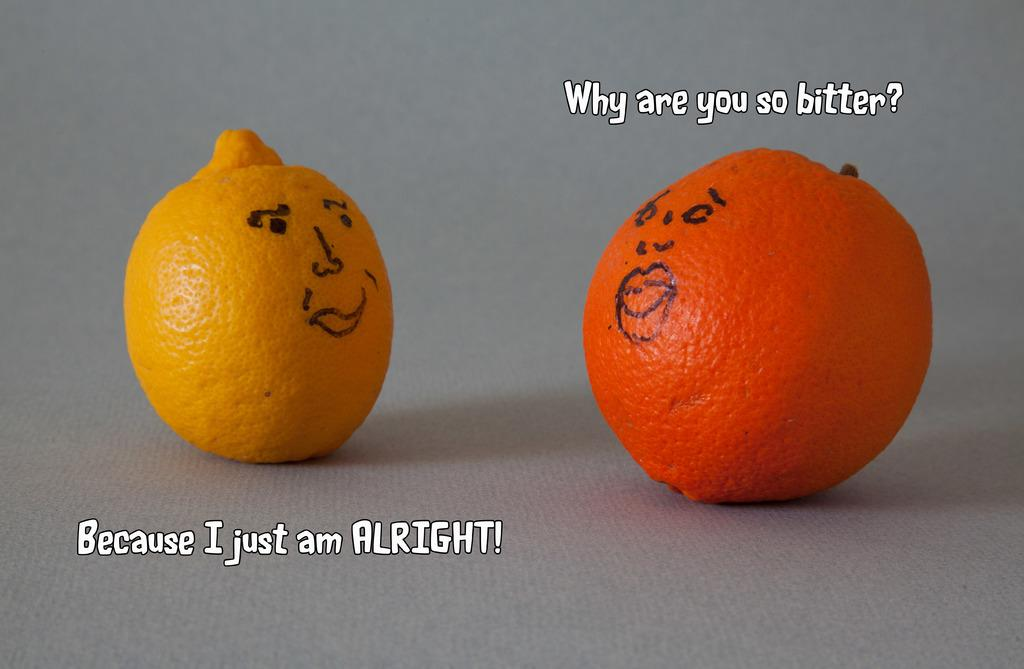How many oranges are in the image? There are two oranges in the image. Where are the oranges located? The oranges are on a platform. What else can be seen in the image besides the oranges? There is text visible in the image. What type of milk is being poured from the goose in the image? There is no goose or milk present in the image. 